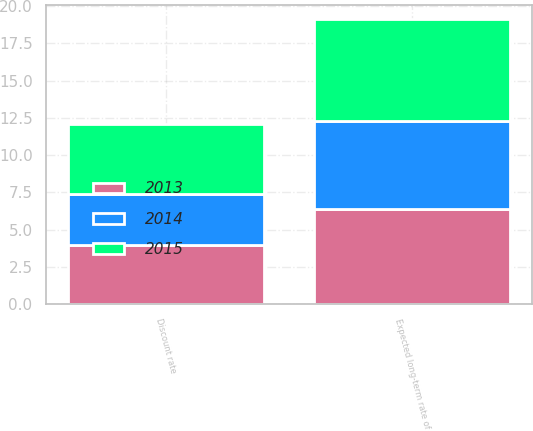Convert chart. <chart><loc_0><loc_0><loc_500><loc_500><stacked_bar_chart><ecel><fcel>Discount rate<fcel>Expected long-term rate of<nl><fcel>2013<fcel>3.96<fcel>6.38<nl><fcel>2015<fcel>4.68<fcel>6.85<nl><fcel>2014<fcel>3.43<fcel>5.9<nl></chart> 